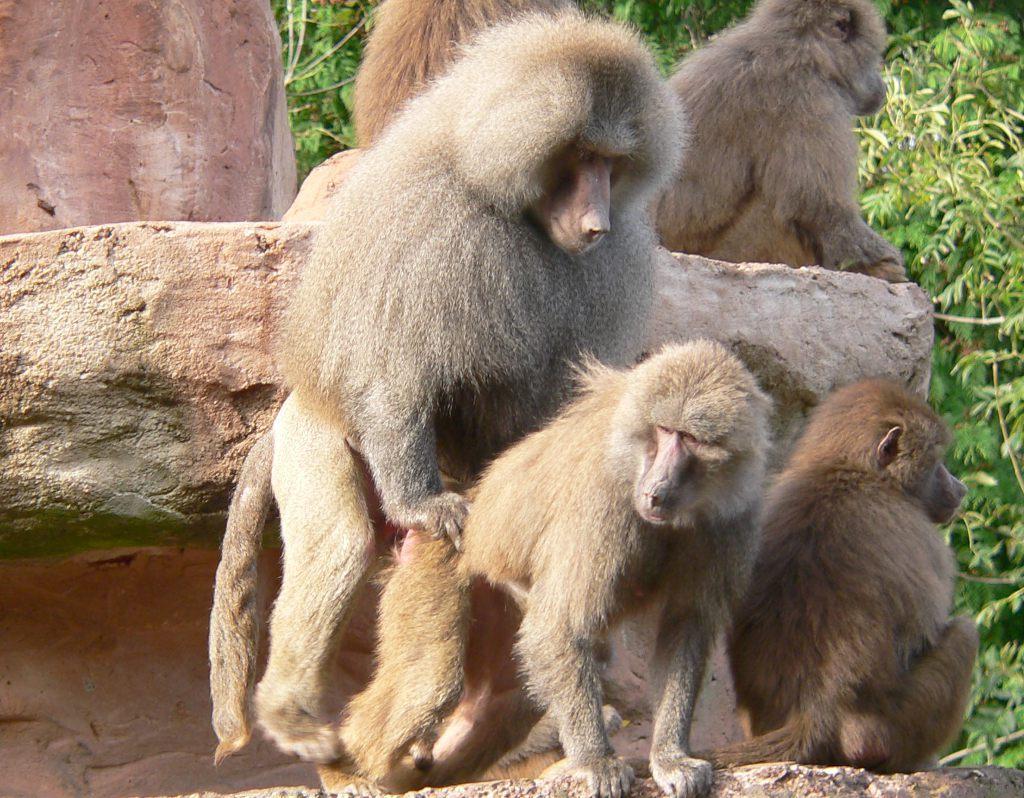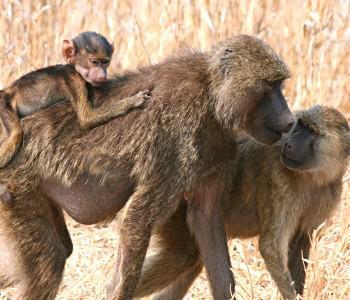The first image is the image on the left, the second image is the image on the right. Examine the images to the left and right. Is the description "An image shows only a solitary monkey sitting on a rock." accurate? Answer yes or no. No. 